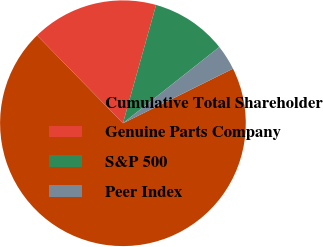Convert chart to OTSL. <chart><loc_0><loc_0><loc_500><loc_500><pie_chart><fcel>Cumulative Total Shareholder<fcel>Genuine Parts Company<fcel>S&P 500<fcel>Peer Index<nl><fcel>70.01%<fcel>16.67%<fcel>10.0%<fcel>3.33%<nl></chart> 